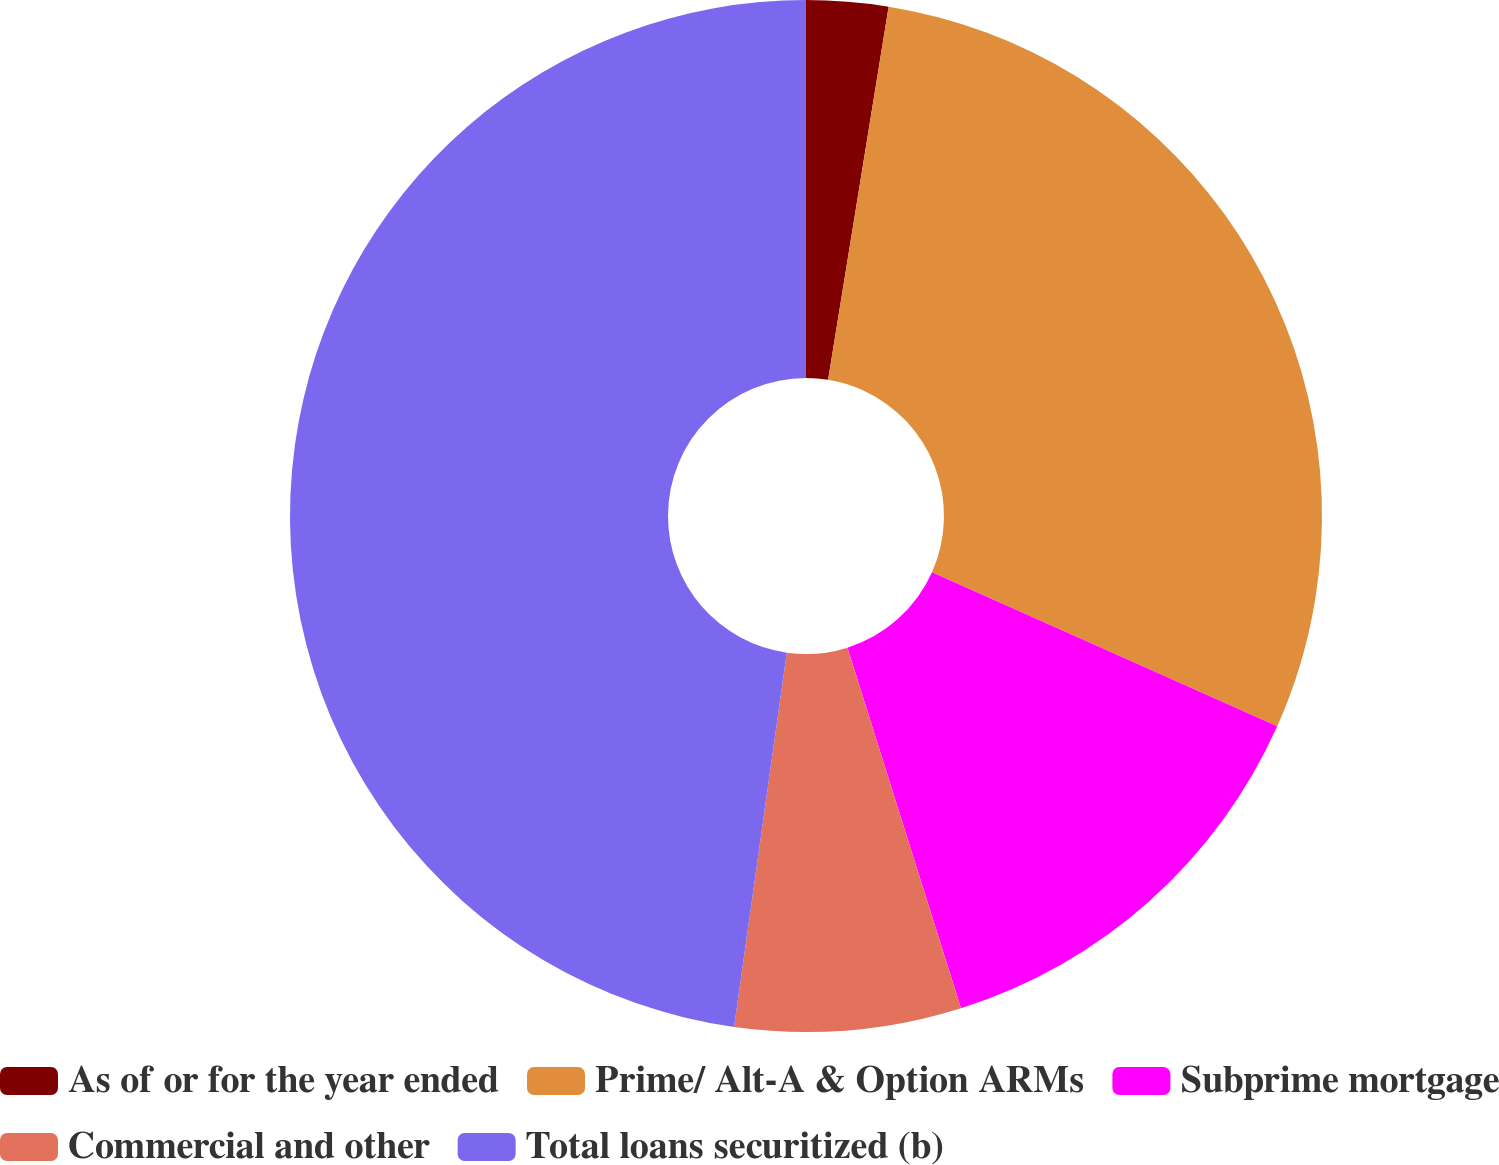Convert chart. <chart><loc_0><loc_0><loc_500><loc_500><pie_chart><fcel>As of or for the year ended<fcel>Prime/ Alt-A & Option ARMs<fcel>Subprime mortgage<fcel>Commercial and other<fcel>Total loans securitized (b)<nl><fcel>2.56%<fcel>29.12%<fcel>13.46%<fcel>7.08%<fcel>47.77%<nl></chart> 